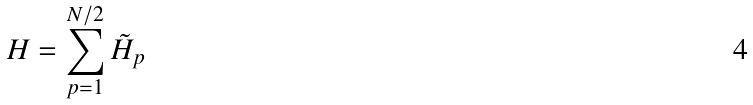Convert formula to latex. <formula><loc_0><loc_0><loc_500><loc_500>H = \sum _ { p = 1 } ^ { N / 2 } \tilde { H } _ { p }</formula> 